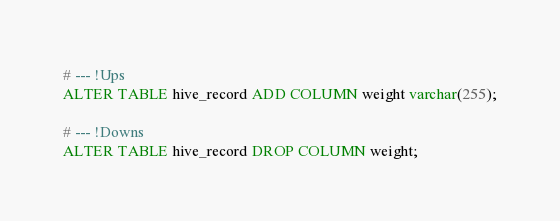<code> <loc_0><loc_0><loc_500><loc_500><_SQL_># --- !Ups
ALTER TABLE hive_record ADD COLUMN weight varchar(255);

# --- !Downs
ALTER TABLE hive_record DROP COLUMN weight;
</code> 